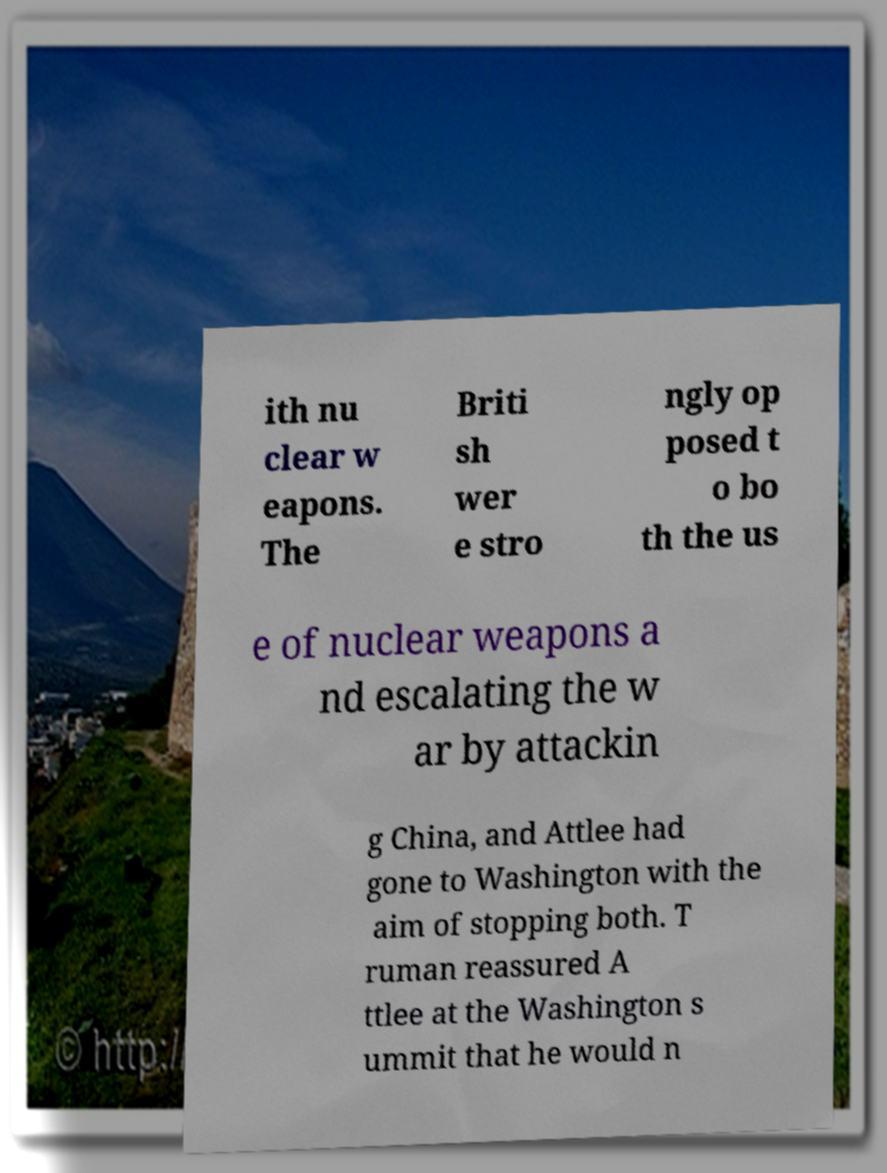Please read and relay the text visible in this image. What does it say? ith nu clear w eapons. The Briti sh wer e stro ngly op posed t o bo th the us e of nuclear weapons a nd escalating the w ar by attackin g China, and Attlee had gone to Washington with the aim of stopping both. T ruman reassured A ttlee at the Washington s ummit that he would n 